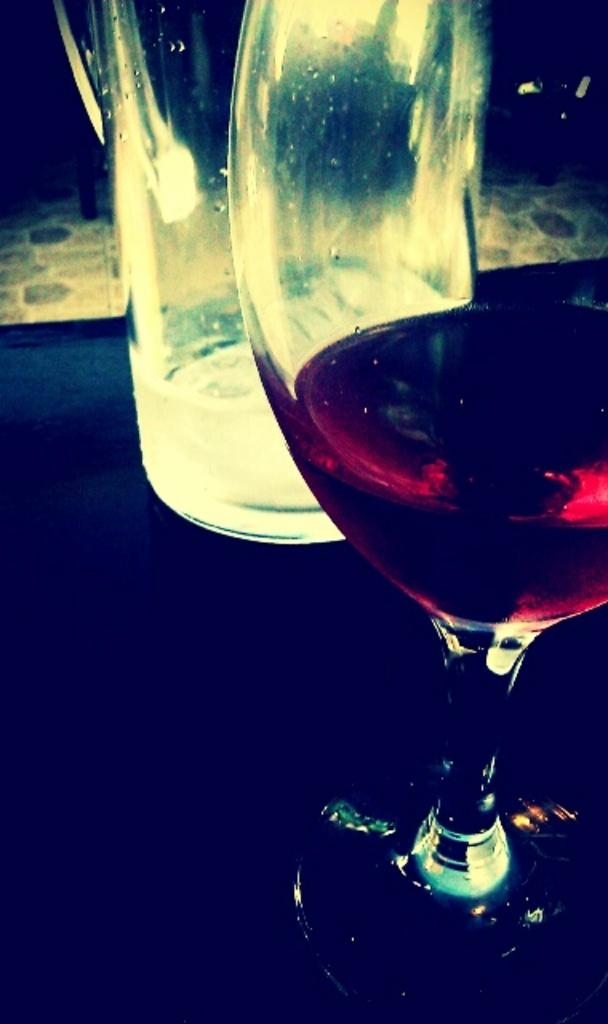What is located on the right side of the image? There is a wine glass on the right side of the image. Can you describe the position of the wine glass in the image? The wine glass is on the right side of the image. What other object can be seen at the top of the image? There is a bottle visible at the top of the image. Where is the throne located in the image? There is no throne present in the image. How many steps can be seen leading up to the throne in the image? There are no steps or throne present in the image. 